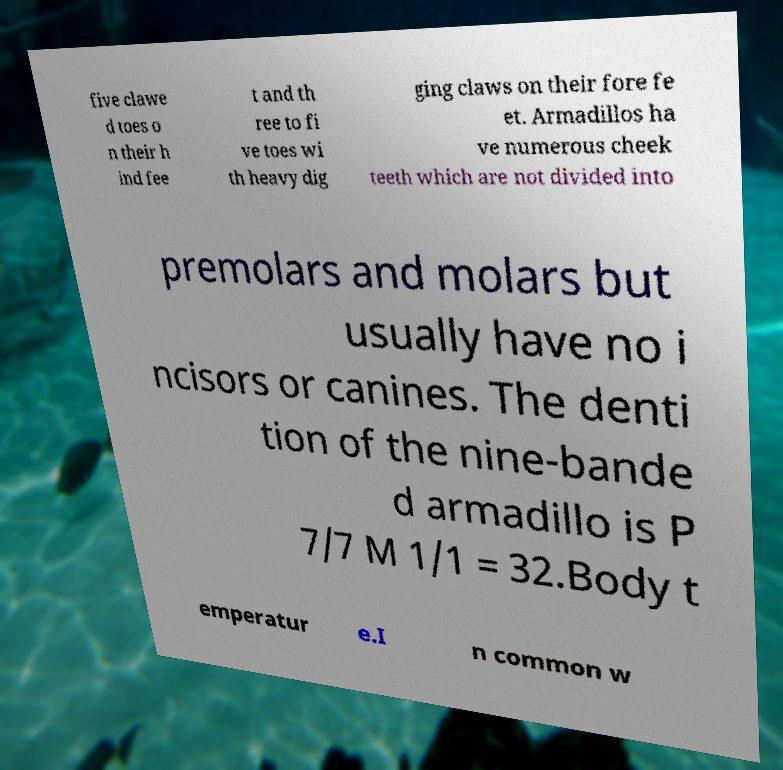I need the written content from this picture converted into text. Can you do that? five clawe d toes o n their h ind fee t and th ree to fi ve toes wi th heavy dig ging claws on their fore fe et. Armadillos ha ve numerous cheek teeth which are not divided into premolars and molars but usually have no i ncisors or canines. The denti tion of the nine-bande d armadillo is P 7/7 M 1/1 = 32.Body t emperatur e.I n common w 